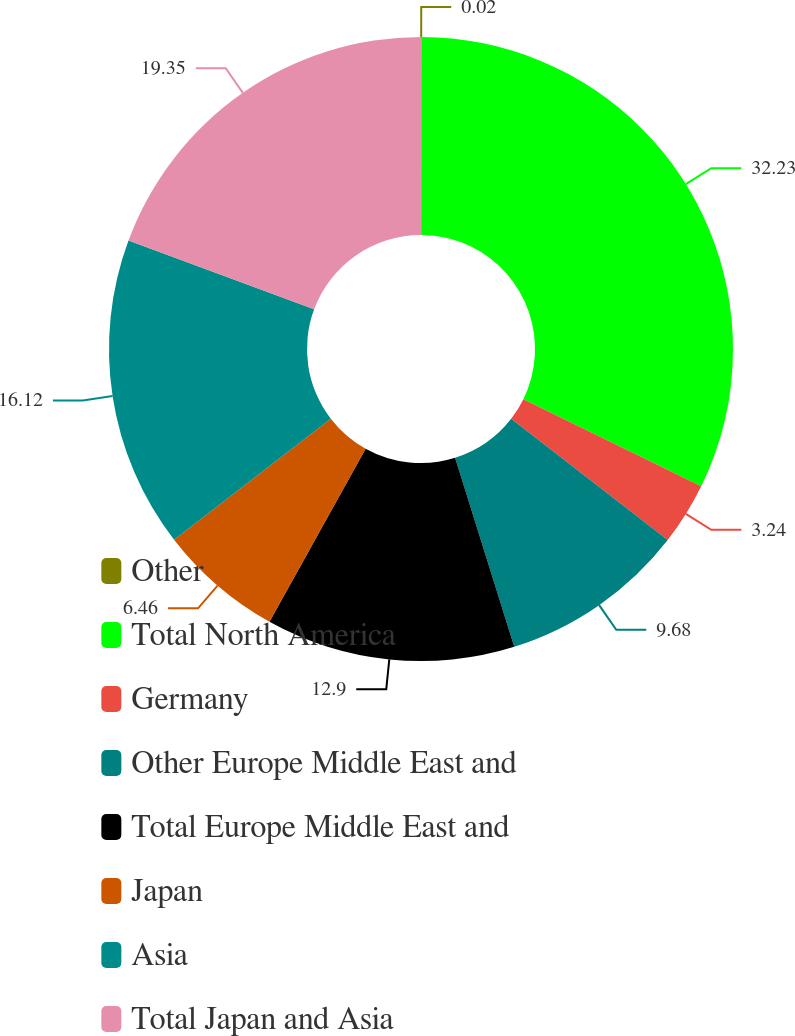<chart> <loc_0><loc_0><loc_500><loc_500><pie_chart><fcel>Other<fcel>Total North America<fcel>Germany<fcel>Other Europe Middle East and<fcel>Total Europe Middle East and<fcel>Japan<fcel>Asia<fcel>Total Japan and Asia<nl><fcel>0.02%<fcel>32.22%<fcel>3.24%<fcel>9.68%<fcel>12.9%<fcel>6.46%<fcel>16.12%<fcel>19.34%<nl></chart> 